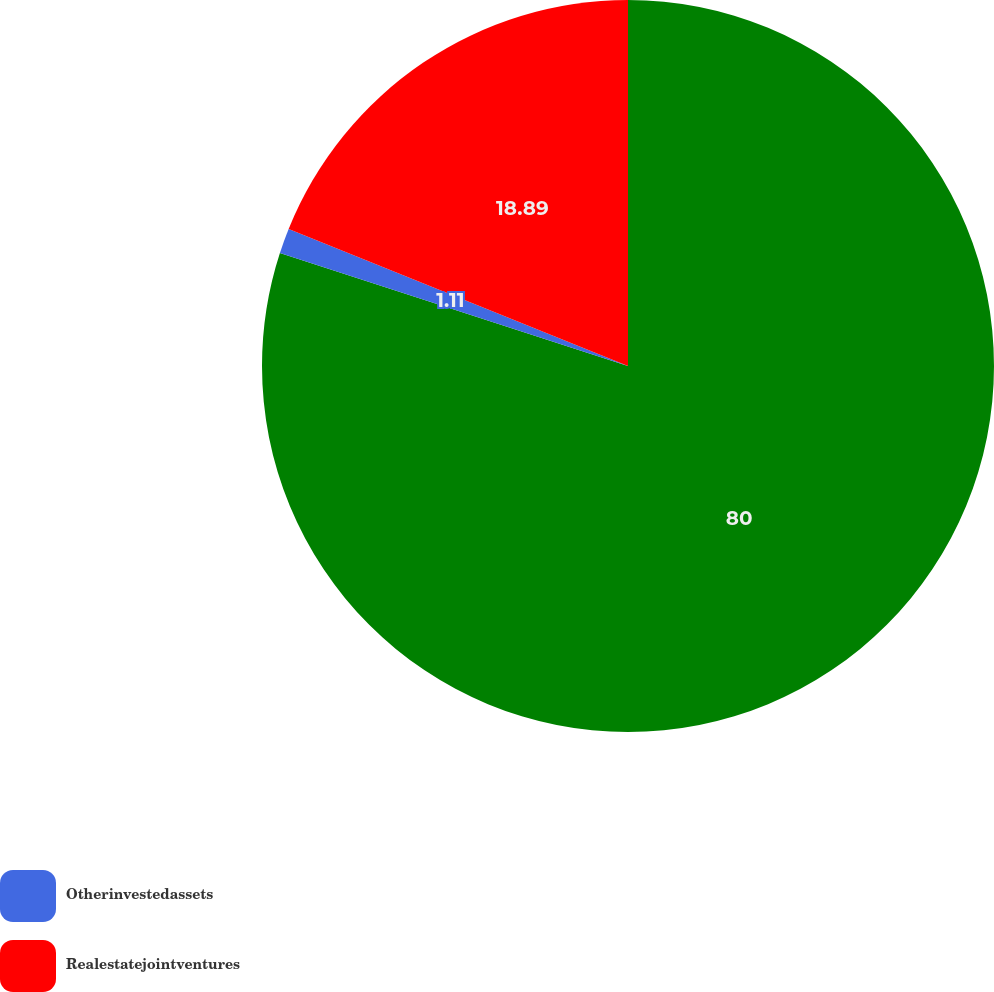Convert chart to OTSL. <chart><loc_0><loc_0><loc_500><loc_500><pie_chart><ecel><fcel>Otherinvestedassets<fcel>Realestatejointventures<nl><fcel>80.0%<fcel>1.11%<fcel>18.89%<nl></chart> 